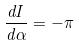Convert formula to latex. <formula><loc_0><loc_0><loc_500><loc_500>\frac { d I } { d \alpha } = - \pi</formula> 